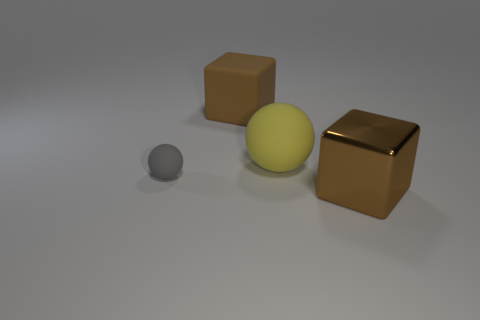Is there anything else that is the same size as the gray thing?
Your answer should be very brief. No. There is a big brown object in front of the tiny rubber thing; is it the same shape as the big brown rubber object?
Offer a terse response. Yes. There is another thing that is the same shape as the gray rubber thing; what material is it?
Make the answer very short. Rubber. How many things are things behind the small sphere or objects left of the brown shiny thing?
Keep it short and to the point. 3. Does the large matte block have the same color as the big cube right of the big yellow matte ball?
Your answer should be compact. Yes. The small gray thing that is the same material as the large yellow sphere is what shape?
Your response must be concise. Sphere. How many tiny red metallic cubes are there?
Your response must be concise. 0. What number of things are either matte spheres that are on the right side of the tiny matte sphere or blue rubber cubes?
Provide a succinct answer. 1. There is a object on the right side of the big ball; is its color the same as the big matte cube?
Keep it short and to the point. Yes. How many other objects are the same color as the large metal cube?
Ensure brevity in your answer.  1. 